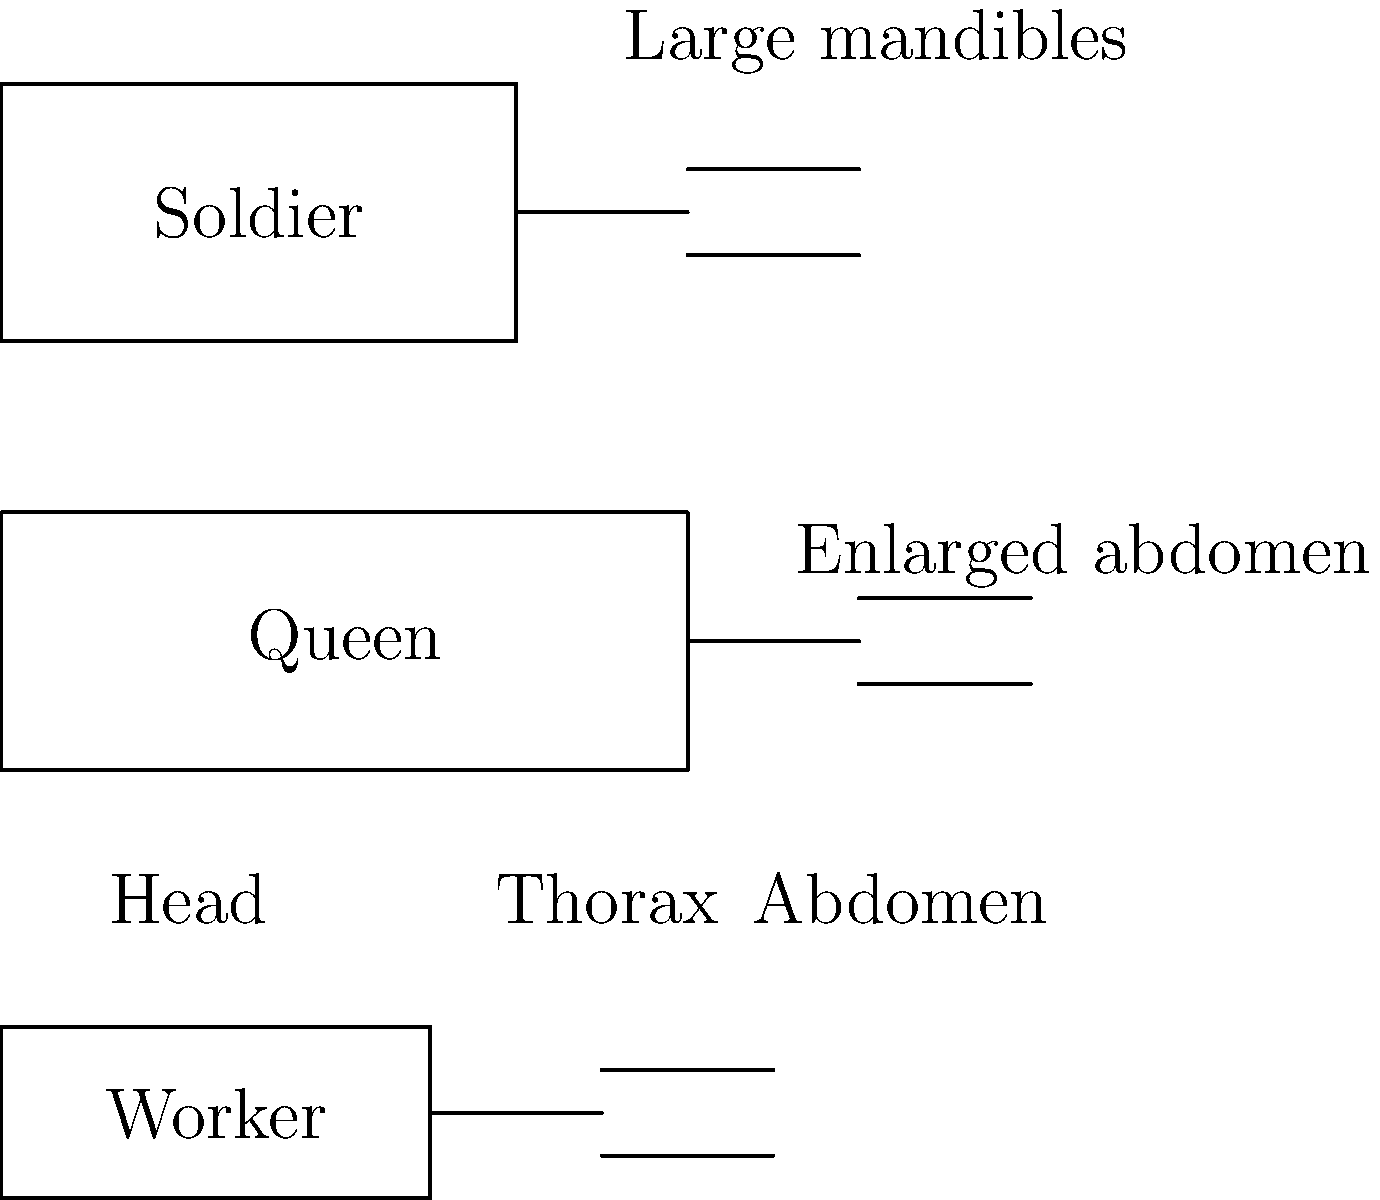Examine the labeled diagrams of three ant castes. Which anatomical feature distinguishes the queen ant from the worker and soldier ants, and what is its primary function? To answer this question, let's analyze the anatomical differences between the three ant castes shown in the diagram:

1. Worker ant: Smallest in size, with a balanced proportion between head, thorax, and abdomen.

2. Soldier ant: Slightly larger than the worker, with noticeably enlarged mandibles (jaws) for defense and combat.

3. Queen ant: Largest in size, with a significantly enlarged abdomen compared to the other castes.

The distinguishing feature of the queen ant is her enlarged abdomen. This anatomical adaptation serves a crucial function in the ant colony:

1. Egg production: The enlarged abdomen houses the queen's ovaries, allowing her to produce a large number of eggs to maintain the colony's population.

2. Food storage: The larger abdomen can store more nutrients, which is essential for sustained egg production.

3. Pheromone production: The queen's abdomen contains glands that produce pheromones to regulate colony behavior and maintain her dominance.

This enlarged abdomen is directly related to the queen's primary role in the colony: reproduction. Worker and soldier ants, which do not reproduce, do not require this anatomical adaptation.
Answer: Enlarged abdomen for egg production 